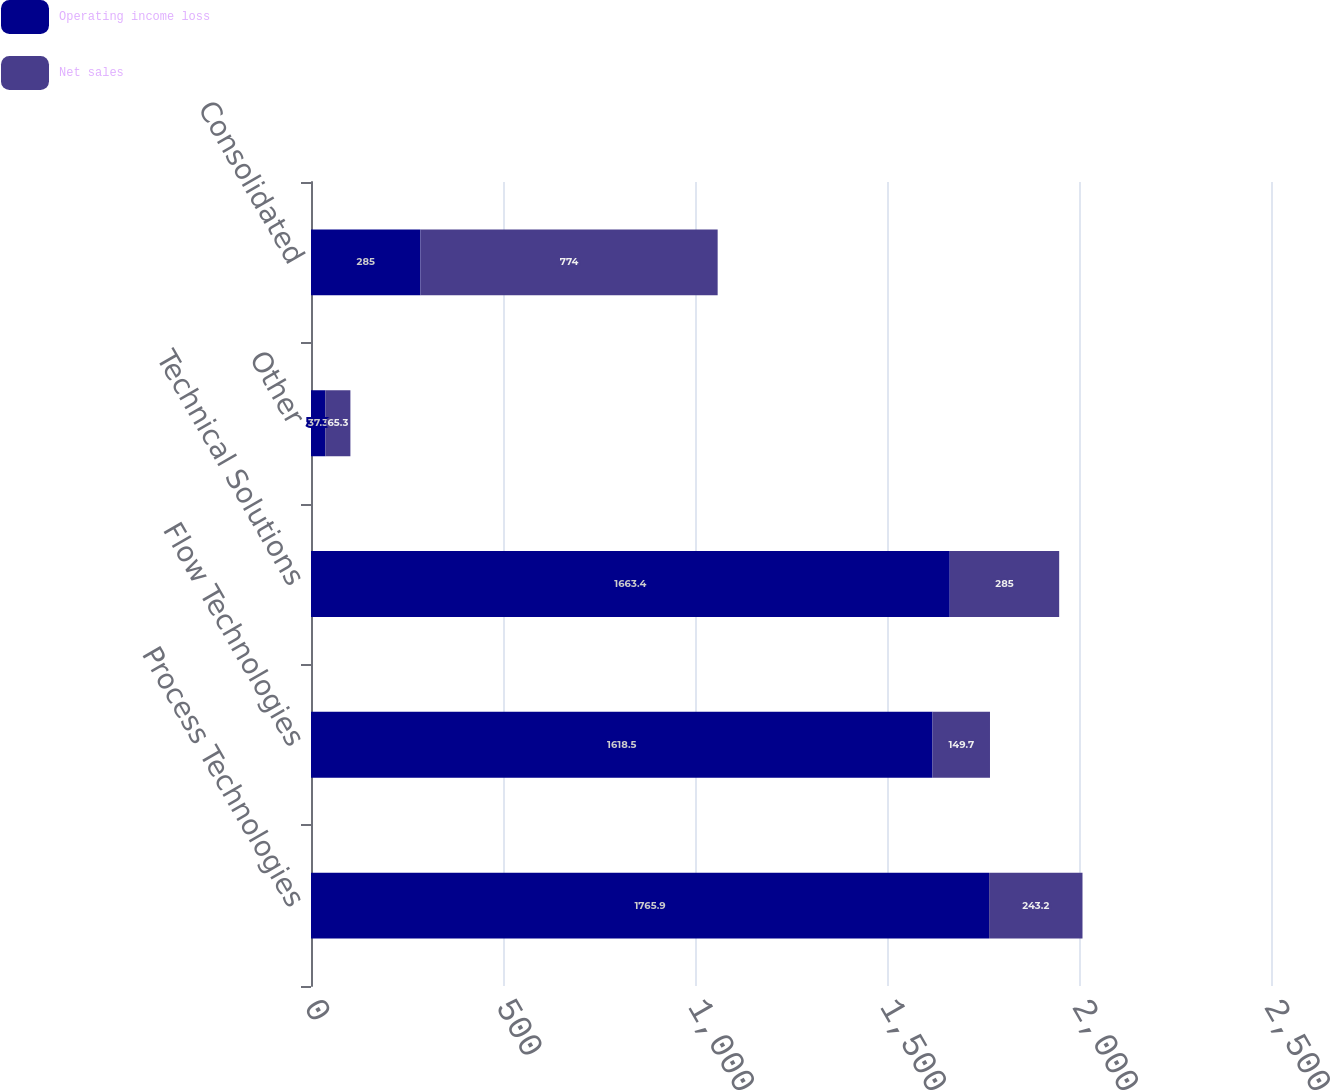Convert chart to OTSL. <chart><loc_0><loc_0><loc_500><loc_500><stacked_bar_chart><ecel><fcel>Process Technologies<fcel>Flow Technologies<fcel>Technical Solutions<fcel>Other<fcel>Consolidated<nl><fcel>Operating income loss<fcel>1765.9<fcel>1618.5<fcel>1663.4<fcel>37.3<fcel>285<nl><fcel>Net sales<fcel>243.2<fcel>149.7<fcel>285<fcel>65.3<fcel>774<nl></chart> 